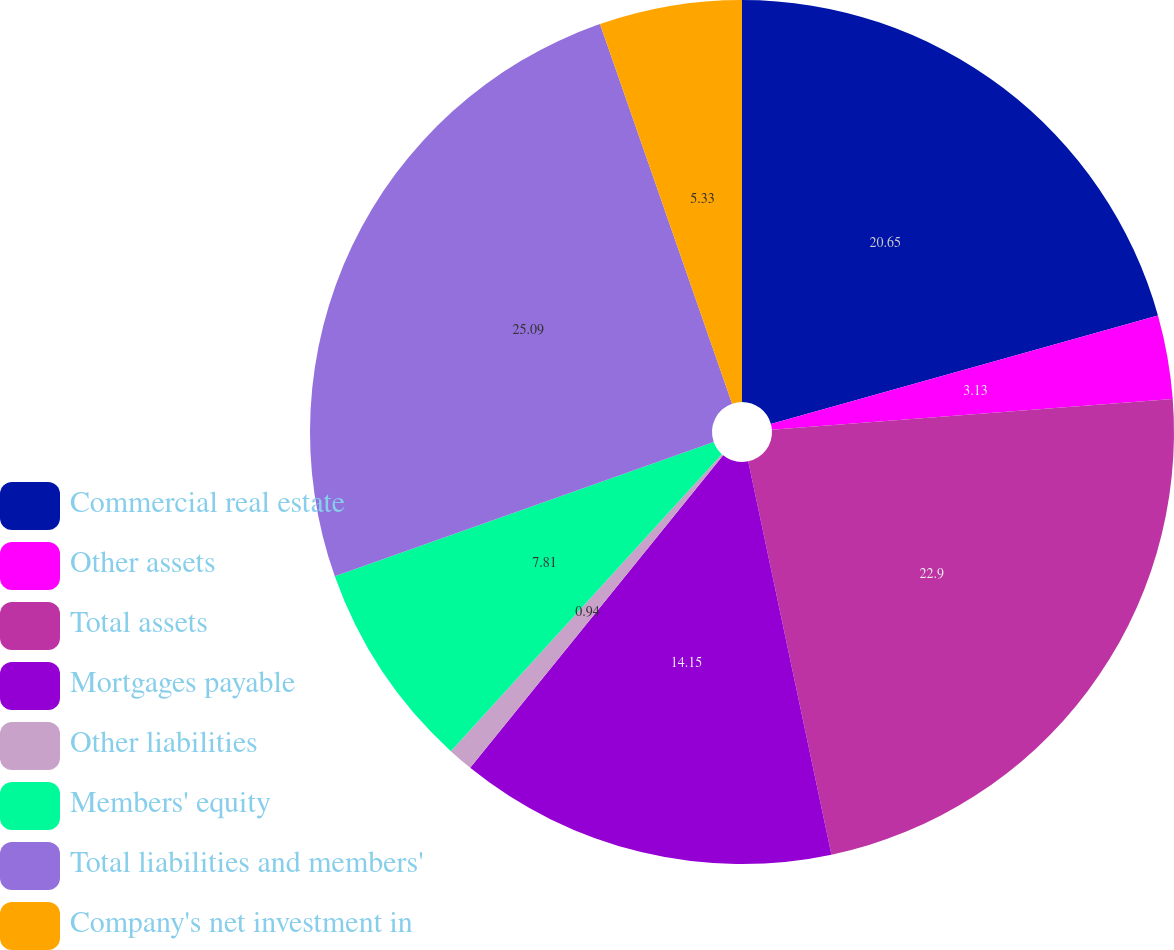Convert chart. <chart><loc_0><loc_0><loc_500><loc_500><pie_chart><fcel>Commercial real estate<fcel>Other assets<fcel>Total assets<fcel>Mortgages payable<fcel>Other liabilities<fcel>Members' equity<fcel>Total liabilities and members'<fcel>Company's net investment in<nl><fcel>20.65%<fcel>3.13%<fcel>22.9%<fcel>14.15%<fcel>0.94%<fcel>7.81%<fcel>25.09%<fcel>5.33%<nl></chart> 